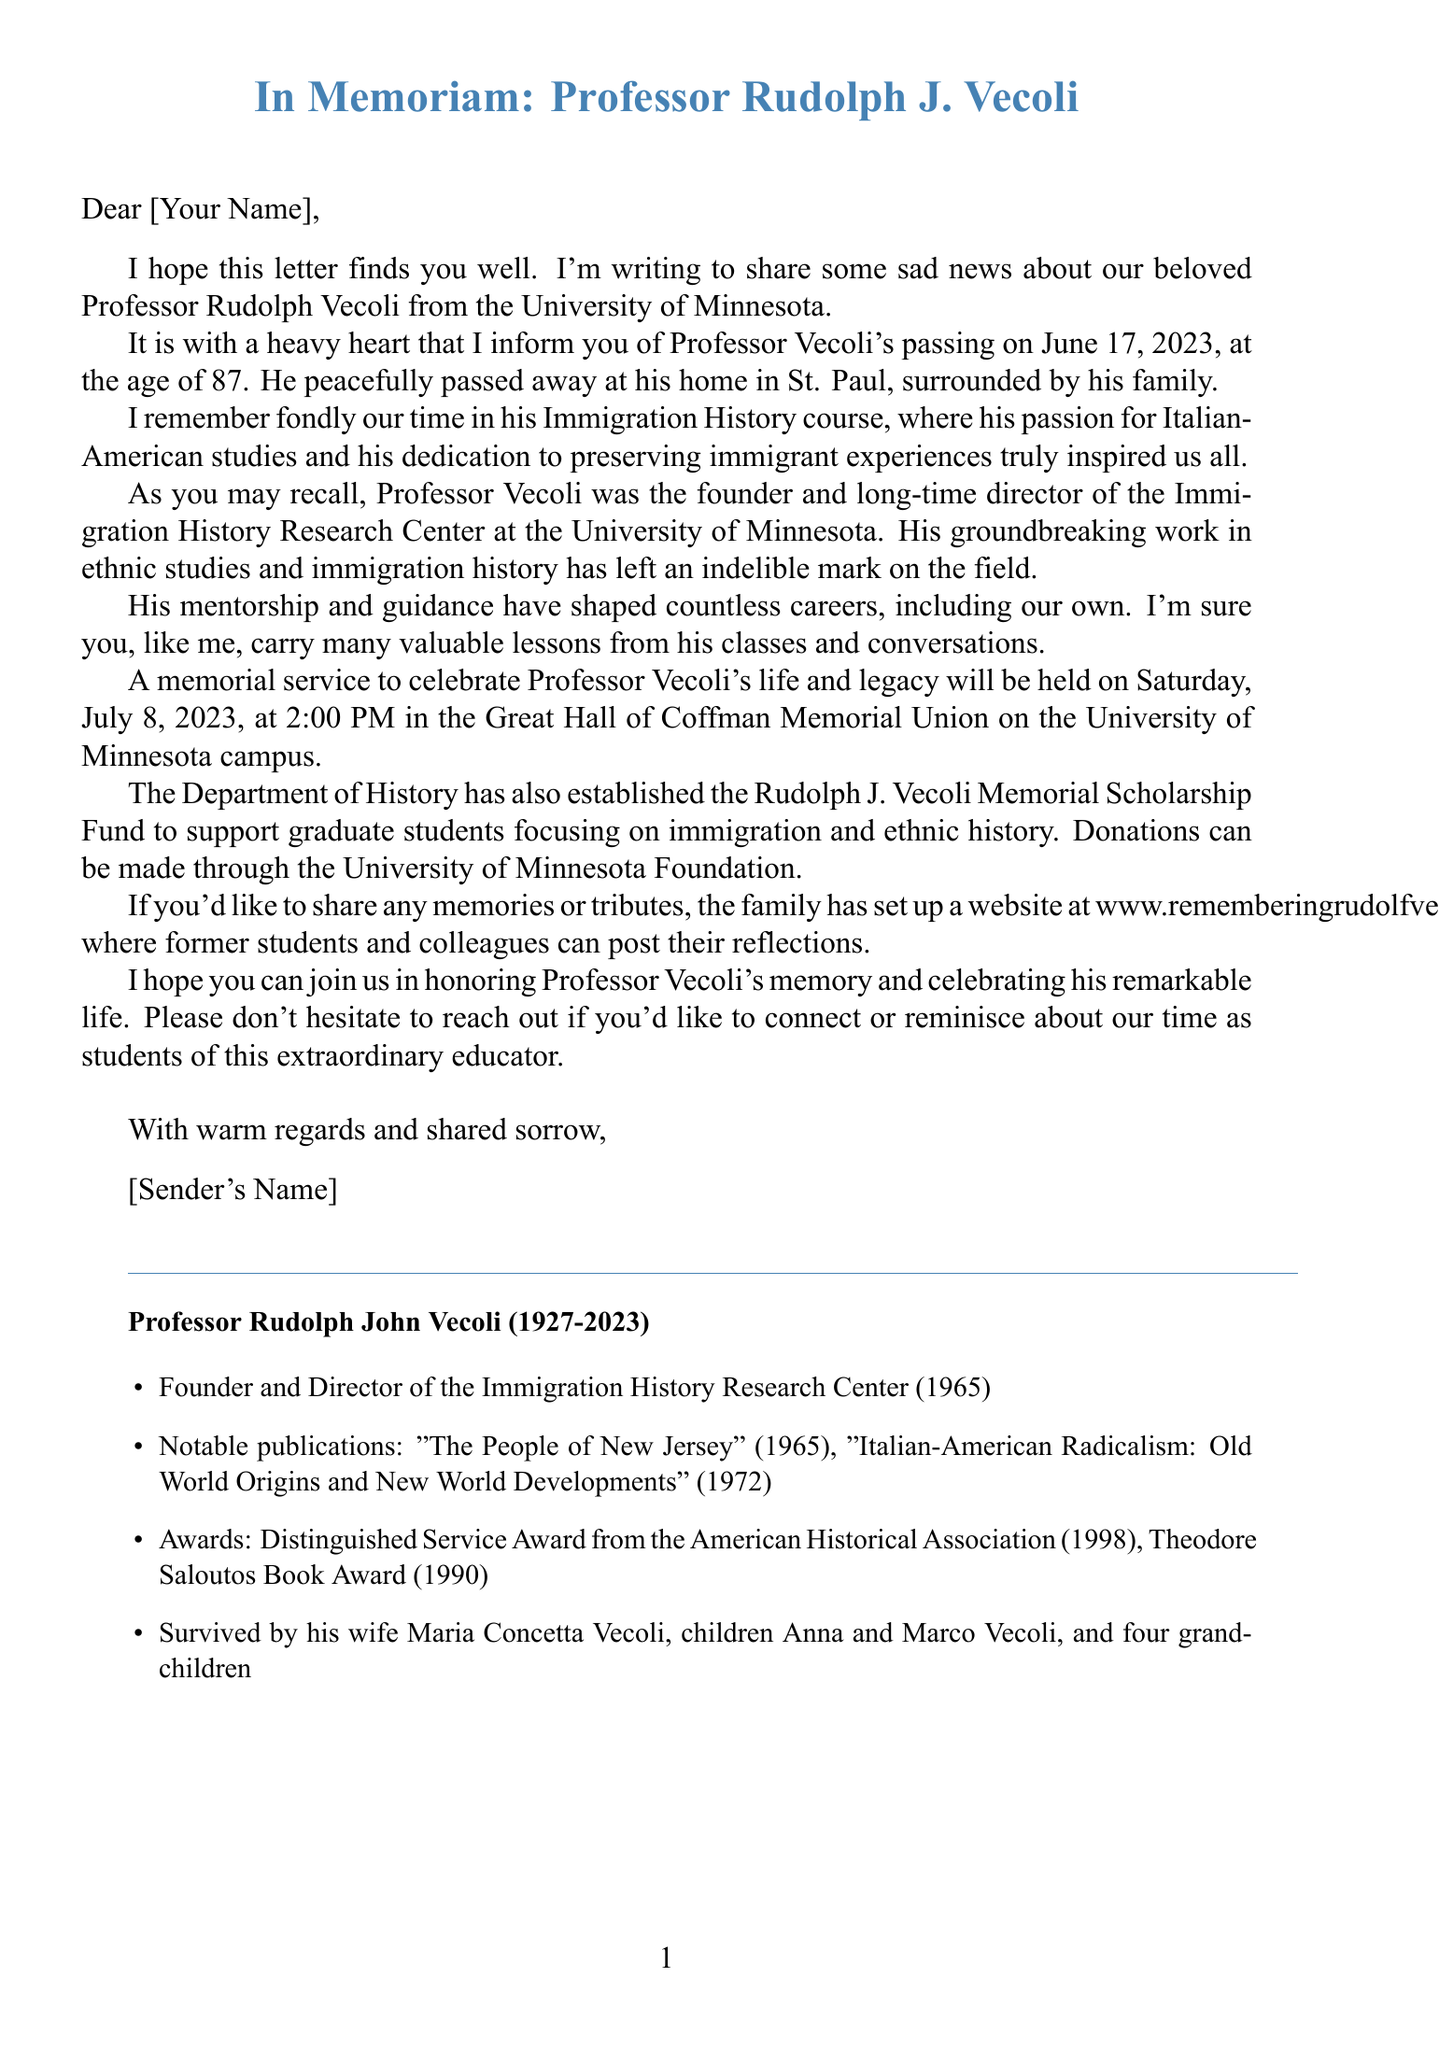what was the date of Professor Vecoli's passing? The date of passing is explicitly mentioned in the document as June 17, 2023.
Answer: June 17, 2023 how old was Professor Vecoli at the time of his passing? The document states that Professor Vecoli passed away at the age of 87.
Answer: 87 where is the memorial service held? The location of the memorial service is specified as the Great Hall of Coffman Memorial Union on the University of Minnesota campus.
Answer: Great Hall of Coffman Memorial Union what is the purpose of the Rudolph J. Vecoli Memorial Scholarship Fund? The document explains that the scholarship fund is for supporting graduate students focusing on immigration and ethnic history.
Answer: Supporting graduate students who are the family members mentioned in the document? The document lists the family members as Maria Concetta Vecoli, Anna Vecoli, and Marco Vecoli, along with four grandchildren.
Answer: Maria Concetta Vecoli, Anna Vecoli, Marco Vecoli what is a notable achievement of Professor Vecoli mentioned in the letter? The document mentions his founding of the Immigration History Research Center at the University of Minnesota as a notable achievement.
Answer: Founder of the Immigration History Research Center what should former students do if they want to share memories or tributes? The document suggests that former students can visit the website set up by the family to post their reflections.
Answer: Visit the website what was one of Professor Vecoli's notable publications? The document lists his publication "Italian-American Radicalism: Old World Origins and New World Developments" as a notable work.
Answer: Italian-American Radicalism: Old World Origins and New World Developments 